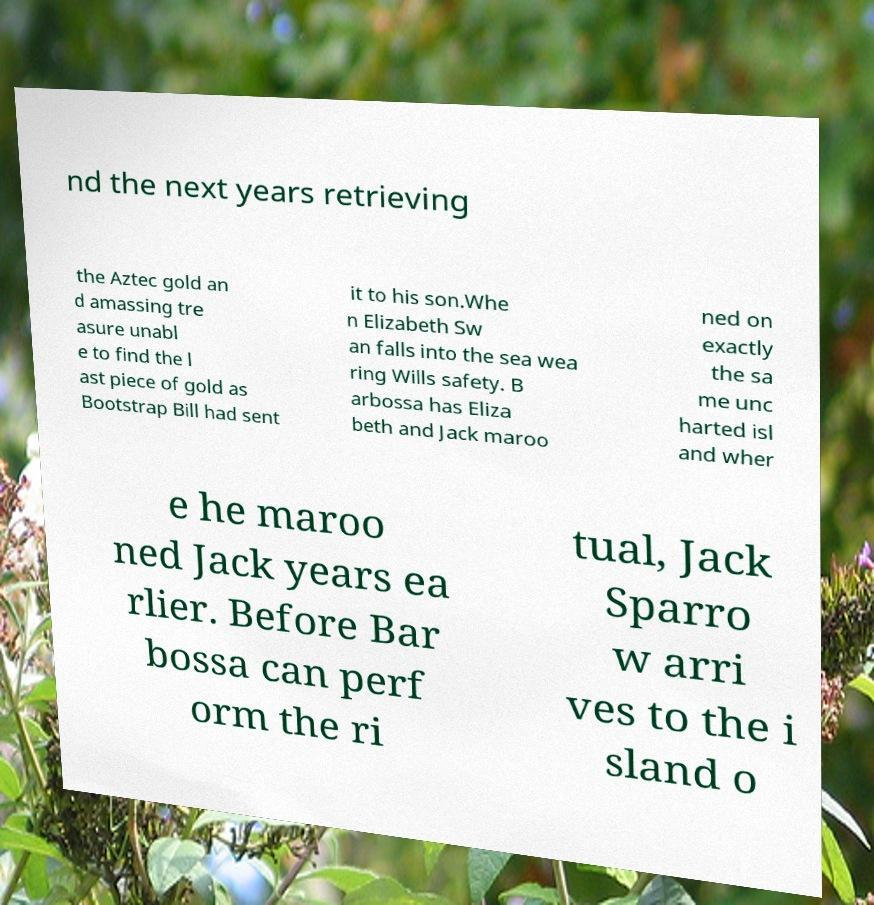Can you accurately transcribe the text from the provided image for me? nd the next years retrieving the Aztec gold an d amassing tre asure unabl e to find the l ast piece of gold as Bootstrap Bill had sent it to his son.Whe n Elizabeth Sw an falls into the sea wea ring Wills safety. B arbossa has Eliza beth and Jack maroo ned on exactly the sa me unc harted isl and wher e he maroo ned Jack years ea rlier. Before Bar bossa can perf orm the ri tual, Jack Sparro w arri ves to the i sland o 